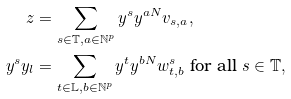<formula> <loc_0><loc_0><loc_500><loc_500>z & = \sum _ { s \in \mathbb { T } , a \in \mathbb { N } ^ { p } } y ^ { s } y ^ { a N } v _ { s , a } , \\ y ^ { s } y _ { l } & = \sum _ { t \in \mathbb { L } , b \in \mathbb { N } ^ { p } } y ^ { t } y ^ { b N } w _ { t , b } ^ { s } \text { for all } s \in \mathbb { T } ,</formula> 